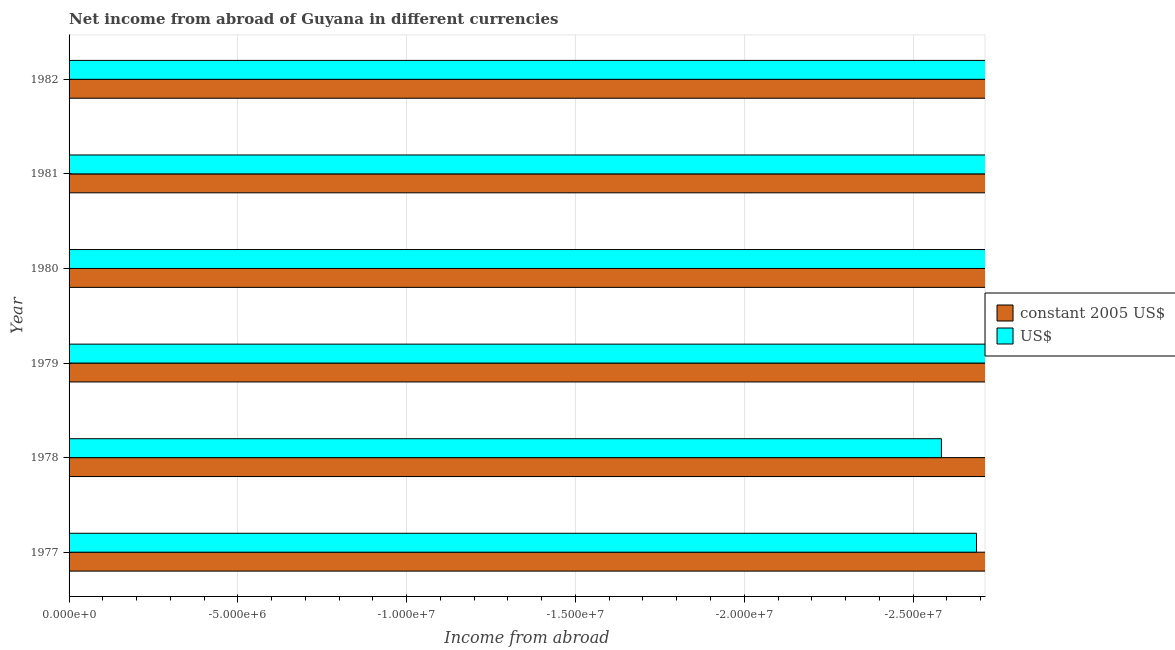How many different coloured bars are there?
Your answer should be compact. 0. How many bars are there on the 6th tick from the bottom?
Offer a very short reply. 0. What is the label of the 2nd group of bars from the top?
Your response must be concise. 1981. In how many cases, is the number of bars for a given year not equal to the number of legend labels?
Your answer should be very brief. 6. What is the income from abroad in us$ in 1977?
Your answer should be very brief. 0. What is the difference between the income from abroad in us$ in 1977 and the income from abroad in constant 2005 us$ in 1979?
Offer a very short reply. 0. How many bars are there?
Your answer should be compact. 0. What is the difference between two consecutive major ticks on the X-axis?
Provide a succinct answer. 5.00e+06. Are the values on the major ticks of X-axis written in scientific E-notation?
Your answer should be very brief. Yes. Does the graph contain any zero values?
Your answer should be compact. Yes. Does the graph contain grids?
Your answer should be compact. Yes. How are the legend labels stacked?
Provide a succinct answer. Vertical. What is the title of the graph?
Your answer should be compact. Net income from abroad of Guyana in different currencies. Does "Long-term debt" appear as one of the legend labels in the graph?
Ensure brevity in your answer.  No. What is the label or title of the X-axis?
Your response must be concise. Income from abroad. What is the Income from abroad of US$ in 1977?
Offer a terse response. 0. What is the Income from abroad in US$ in 1978?
Your answer should be very brief. 0. What is the Income from abroad of constant 2005 US$ in 1979?
Offer a terse response. 0. What is the Income from abroad in US$ in 1979?
Your answer should be very brief. 0. What is the Income from abroad of US$ in 1980?
Your answer should be very brief. 0. What is the Income from abroad in constant 2005 US$ in 1982?
Keep it short and to the point. 0. What is the Income from abroad in US$ in 1982?
Keep it short and to the point. 0. What is the total Income from abroad of constant 2005 US$ in the graph?
Your answer should be compact. 0. What is the average Income from abroad in constant 2005 US$ per year?
Your response must be concise. 0. 